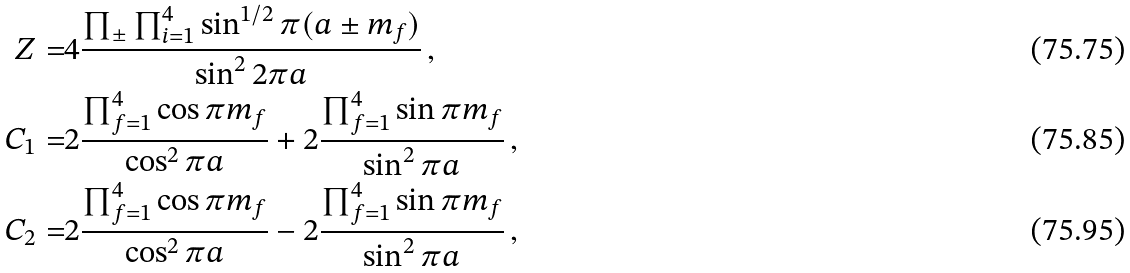Convert formula to latex. <formula><loc_0><loc_0><loc_500><loc_500>Z = & 4 \frac { \prod _ { \pm } \prod _ { i = 1 } ^ { 4 } \sin ^ { 1 / 2 } \pi ( a \pm m _ { f } ) } { \sin ^ { 2 } 2 \pi a } \, , \\ C _ { 1 } = & 2 \frac { \prod _ { f = 1 } ^ { 4 } \cos \pi m _ { f } } { \cos ^ { 2 } \pi a } + 2 \frac { \prod _ { f = 1 } ^ { 4 } \sin \pi m _ { f } } { \sin ^ { 2 } \pi a } \, , \\ C _ { 2 } = & 2 \frac { \prod _ { f = 1 } ^ { 4 } \cos \pi m _ { f } } { \cos ^ { 2 } \pi a } - 2 \frac { \prod _ { f = 1 } ^ { 4 } \sin \pi m _ { f } } { \sin ^ { 2 } \pi a } \, ,</formula> 